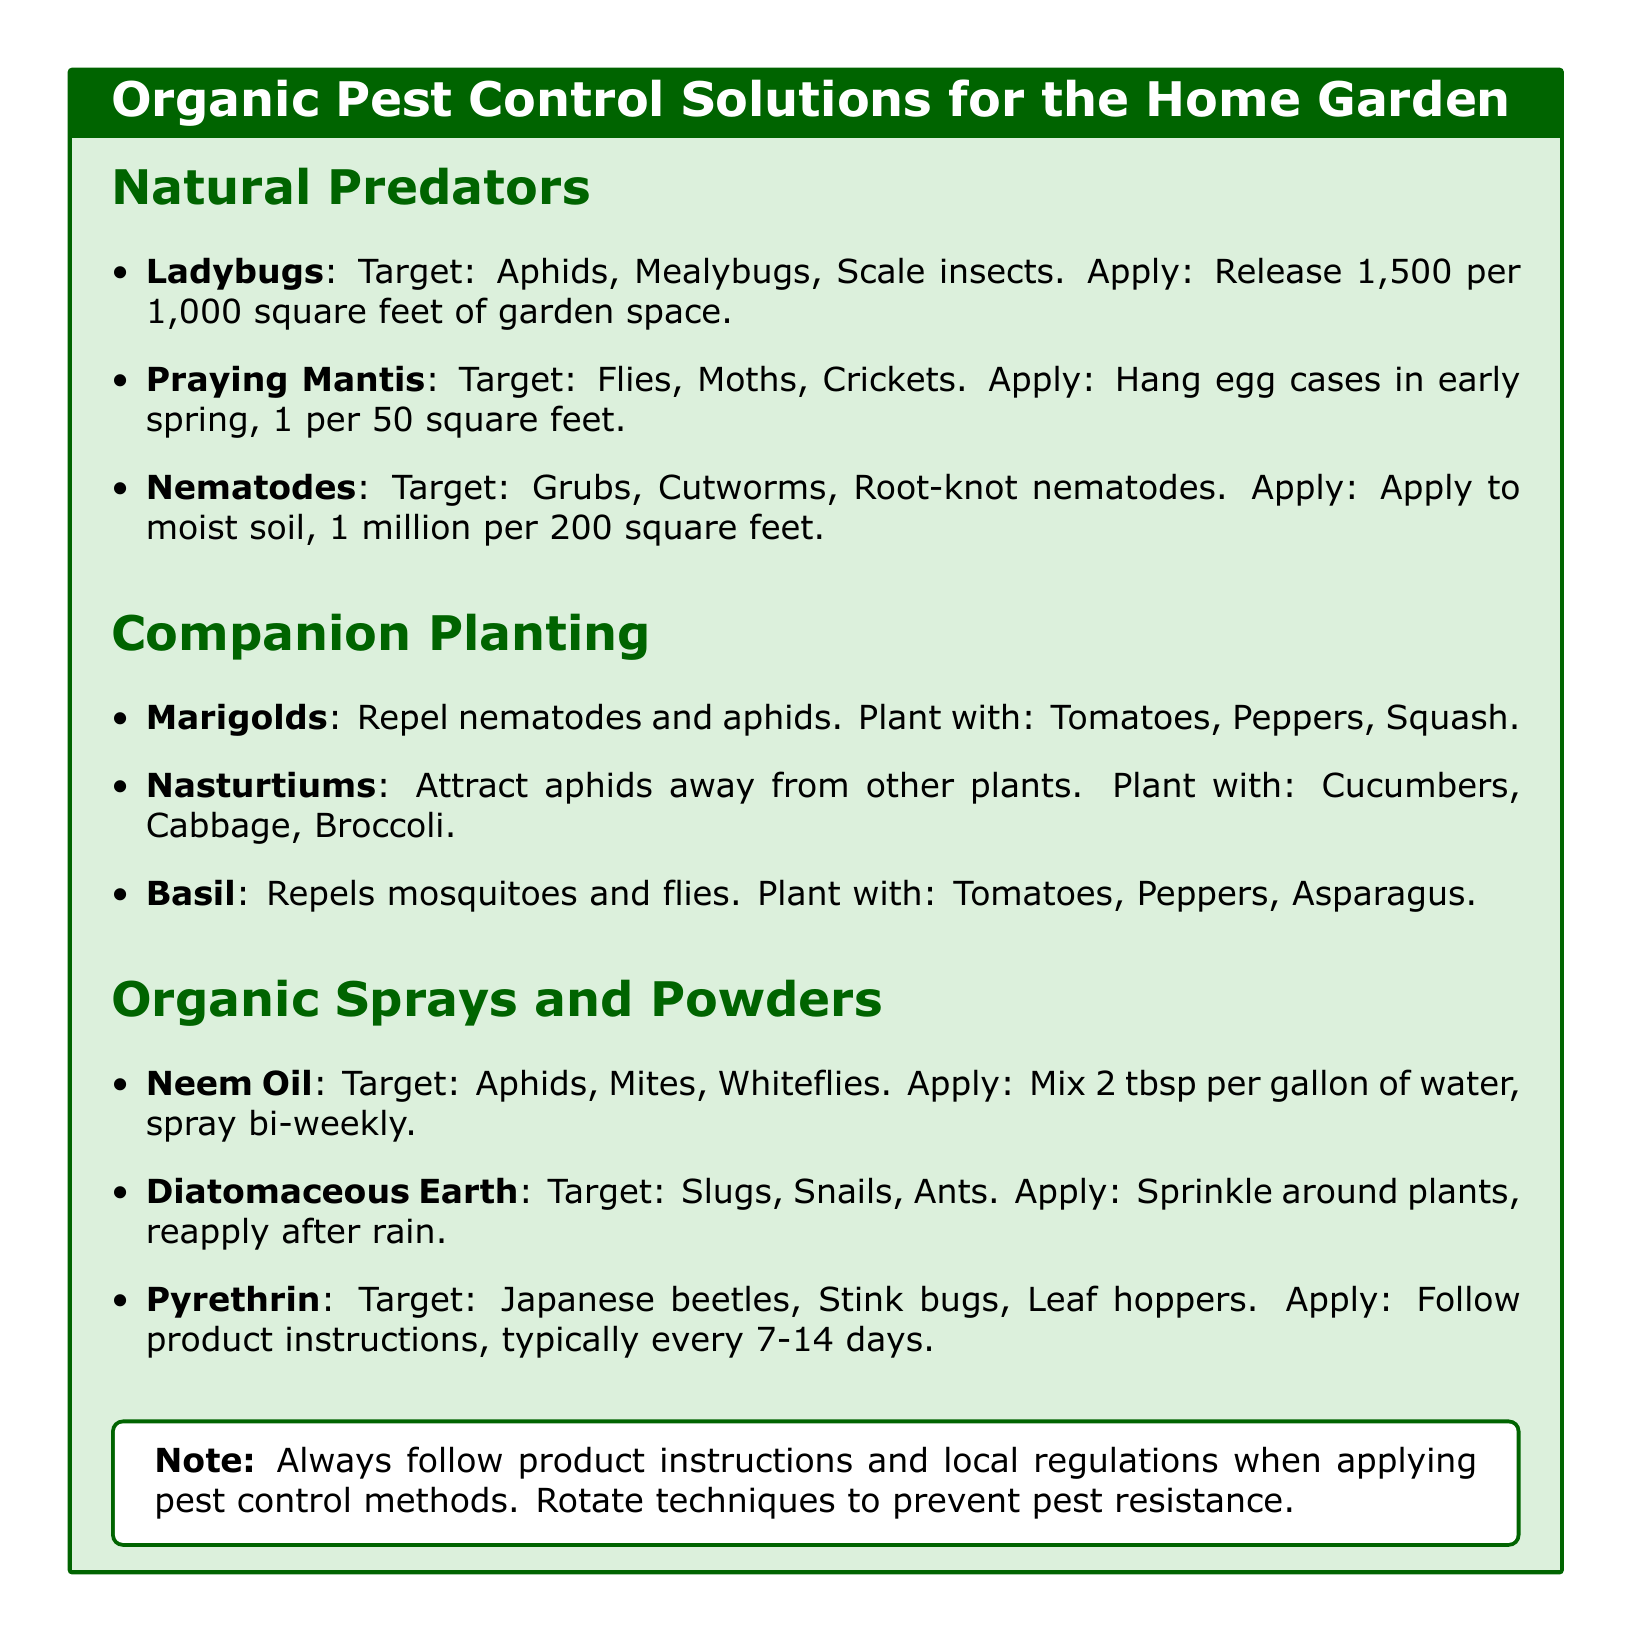What pest do ladybugs target? Ladybugs target specific pests as mentioned in the document, which are aphids, mealybugs, and scale insects.
Answer: Aphids, Mealybugs, Scale insects How many ladybugs should you release per 1,000 square feet? The document specifies the quantity of ladybugs to release for effective pest control in a garden area of 1,000 square feet.
Answer: 1,500 What do marigolds repel? The document states that marigolds have a specific function in pest control, which is to repel certain pests.
Answer: Nematodes and aphids What is the application frequency for neem oil? The document provides specific guidance on how often neem oil should be applied for pest control.
Answer: Bi-weekly What should you reapply after rain? The document mentions the need to maintain effectiveness of a specific pest control method after rain.
Answer: Diatomaceous Earth Which insect does Pyrethrin target? The document lists specific pests that Pyrethrin is meant to control, highlighting a range of problematic insects.
Answer: Japanese beetles, Stink bugs, Leaf hoppers What plants can be grown with basil for optimal pest repelling? The document lists certain crops that maximize the pest-repelling properties of basil through companion planting.
Answer: Tomatoes, Peppers, Asparagus How must Nematodes be applied? The document provides instructions for the application method for using Nematodes in the garden.
Answer: To moist soil What should always be followed when applying pest control methods? The document emphasizes the importance of compliance with certain guidelines when using pest control solutions.
Answer: Product instructions and local regulations 